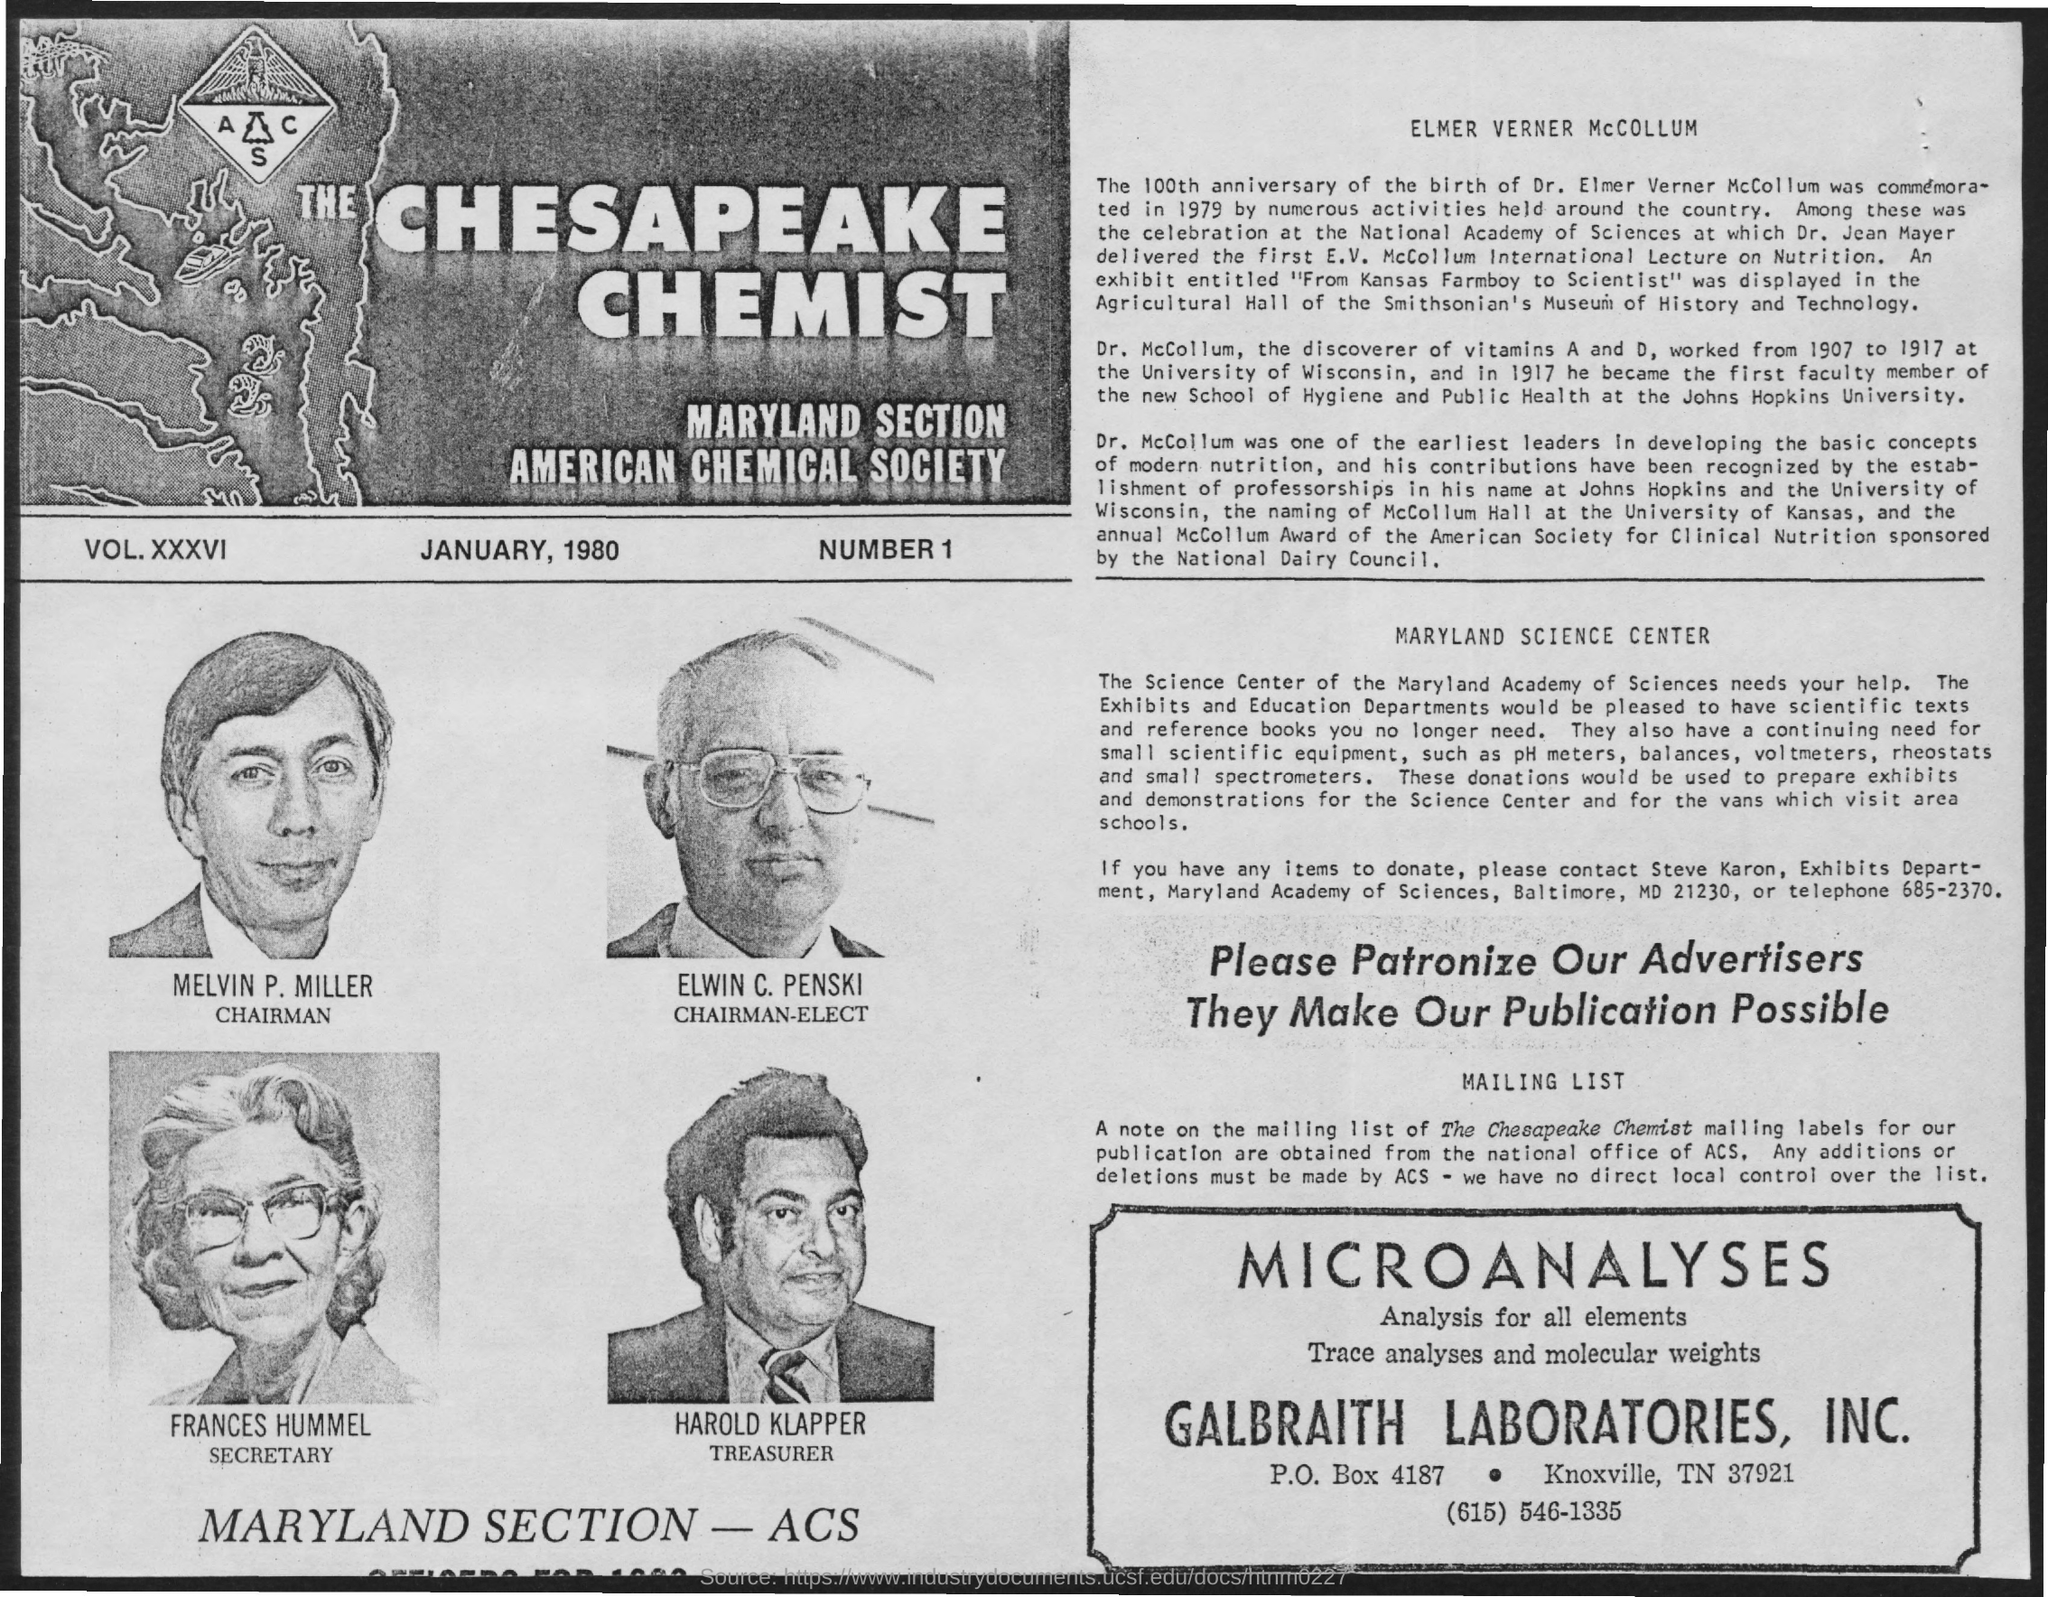What is the p.o. box no. mentioned ?
Provide a short and direct response. 4187. What is the name of the chairman mentioned ?
Make the answer very short. Melvin p. miller. What is the name of chairman-elect mentioned ?
Your answer should be very brief. ELWIN C. PENSKI. What is the name of the secretary mentioned ?
Provide a short and direct response. FRANCES HUMMEL. What is the name of the treasurer mentioned ?
Ensure brevity in your answer.  Harold klapper. What is the name of the society mentioned ?
Make the answer very short. AMERICAN CHEMICAL SOCIETY. What is the name of the section mentioned ?
Provide a succinct answer. Maryland section. 